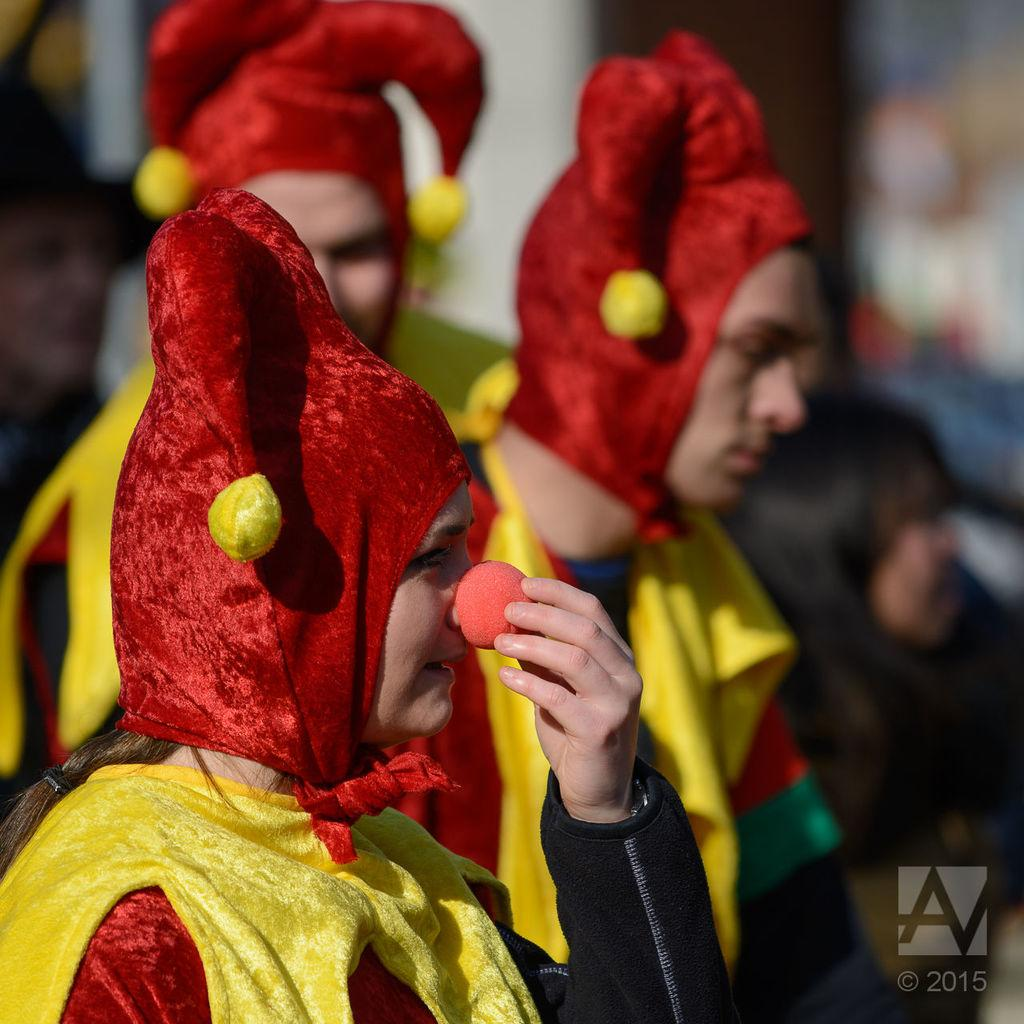What can be seen in the image? There is a group of people in the image. What are the people wearing? The people are wearing fancy dresses. Can you describe the background of the image? The background is blurred in the image. Is there any additional information or marking on the image? Yes, there is a watermark on the image. How many cacti are visible in the image? There are no cacti present in the image. What type of stem is holding up the dresses in the image? The people in the image are not supported by stems; they are standing on their own. 